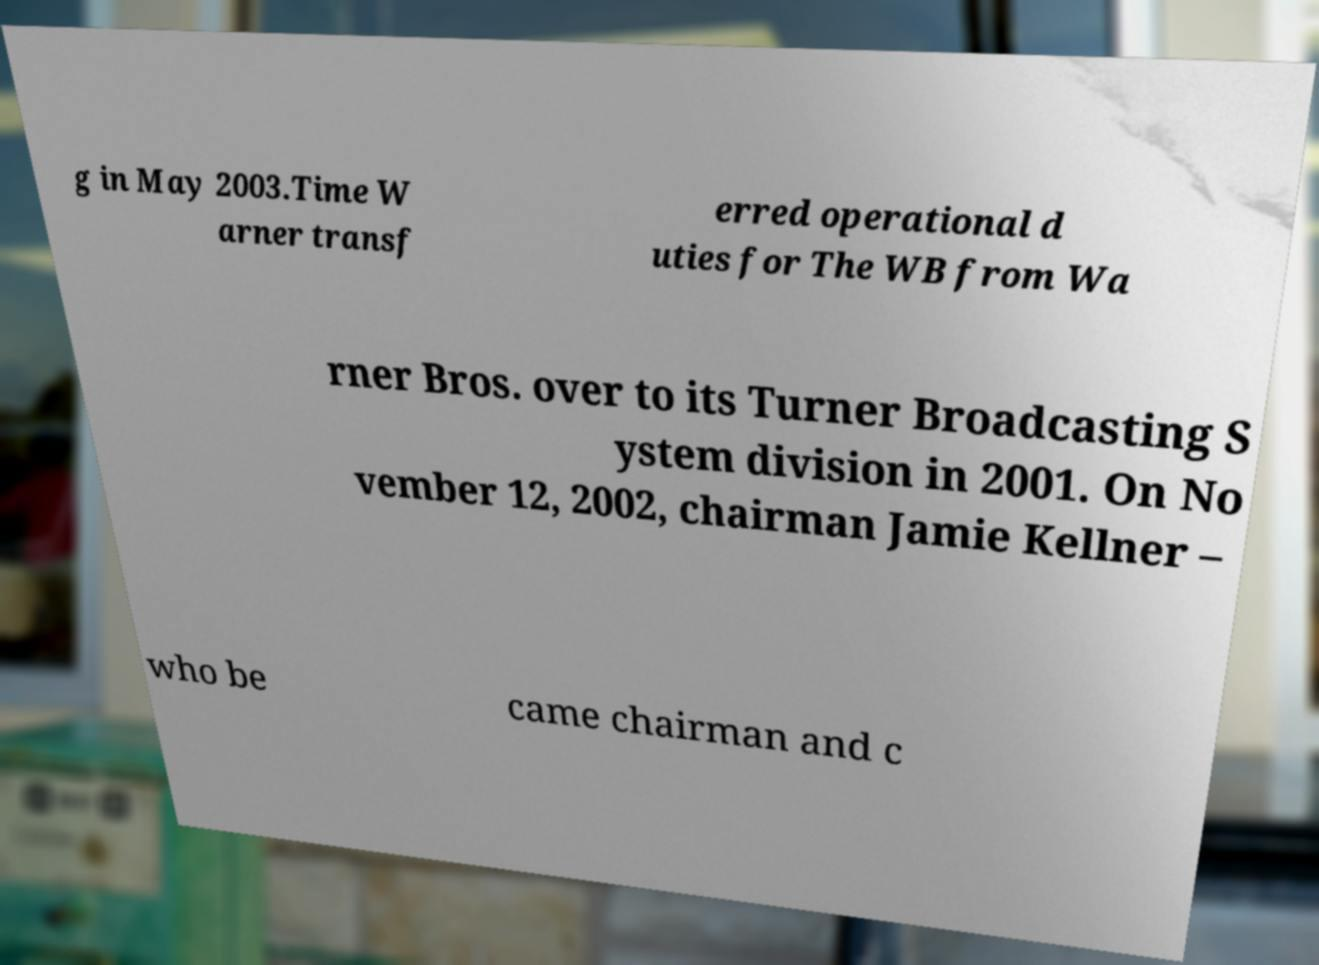Can you read and provide the text displayed in the image?This photo seems to have some interesting text. Can you extract and type it out for me? g in May 2003.Time W arner transf erred operational d uties for The WB from Wa rner Bros. over to its Turner Broadcasting S ystem division in 2001. On No vember 12, 2002, chairman Jamie Kellner – who be came chairman and c 